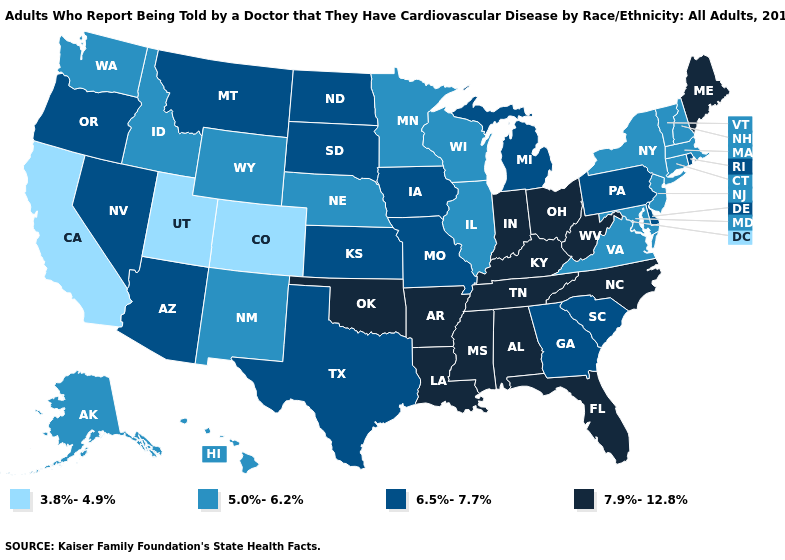Does Iowa have the highest value in the USA?
Short answer required. No. How many symbols are there in the legend?
Answer briefly. 4. What is the value of Alaska?
Write a very short answer. 5.0%-6.2%. What is the highest value in states that border Illinois?
Be succinct. 7.9%-12.8%. Does Texas have a lower value than New York?
Keep it brief. No. Among the states that border Indiana , which have the highest value?
Concise answer only. Kentucky, Ohio. Name the states that have a value in the range 7.9%-12.8%?
Be succinct. Alabama, Arkansas, Florida, Indiana, Kentucky, Louisiana, Maine, Mississippi, North Carolina, Ohio, Oklahoma, Tennessee, West Virginia. What is the lowest value in the West?
Give a very brief answer. 3.8%-4.9%. Which states hav the highest value in the Northeast?
Give a very brief answer. Maine. Does Tennessee have the lowest value in the USA?
Short answer required. No. What is the highest value in the West ?
Quick response, please. 6.5%-7.7%. Name the states that have a value in the range 7.9%-12.8%?
Answer briefly. Alabama, Arkansas, Florida, Indiana, Kentucky, Louisiana, Maine, Mississippi, North Carolina, Ohio, Oklahoma, Tennessee, West Virginia. Name the states that have a value in the range 6.5%-7.7%?
Concise answer only. Arizona, Delaware, Georgia, Iowa, Kansas, Michigan, Missouri, Montana, Nevada, North Dakota, Oregon, Pennsylvania, Rhode Island, South Carolina, South Dakota, Texas. Does Pennsylvania have the highest value in the Northeast?
Be succinct. No. Among the states that border Illinois , does Wisconsin have the highest value?
Short answer required. No. 